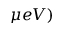<formula> <loc_0><loc_0><loc_500><loc_500>\mu e V )</formula> 